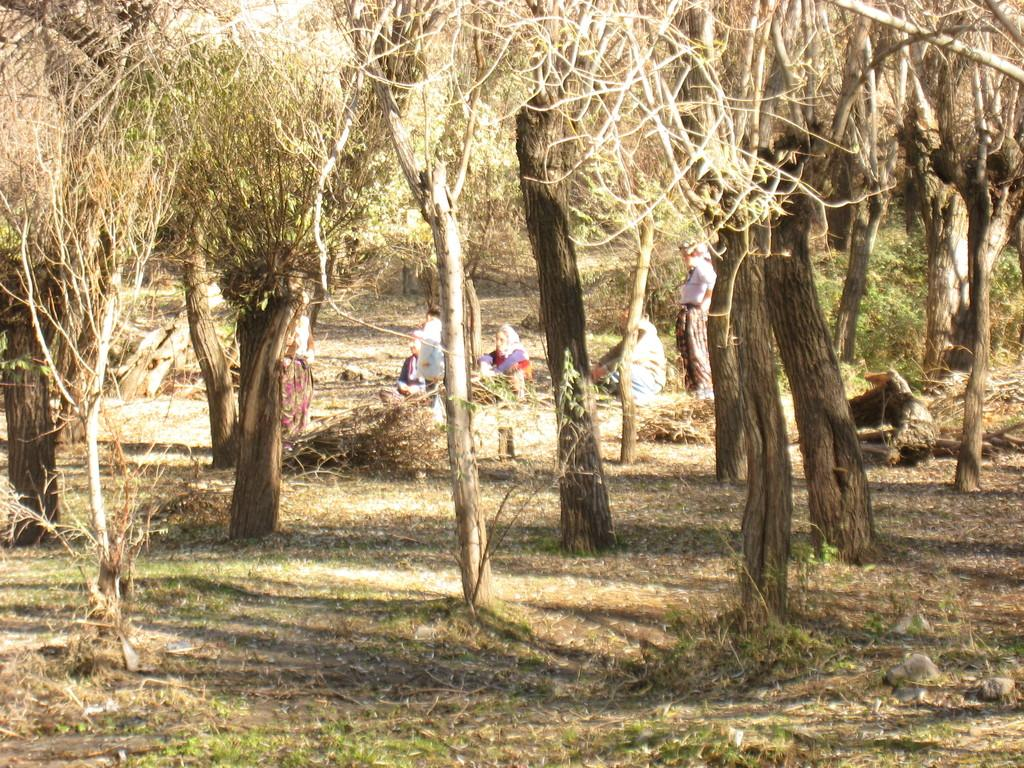What type of vegetation is present in the image? There are trees in the image. What can be found on the ground on the right side of the image? There are stones on the ground on the right side of the image. What are the people in the background doing in the image? A: In the background, there are persons sitting and standing on the ground. What color is the train in the image? There is no train present in the image. How many meters long is the colorful snake in the image? There is no snake, colorful or otherwise, present in the image. 